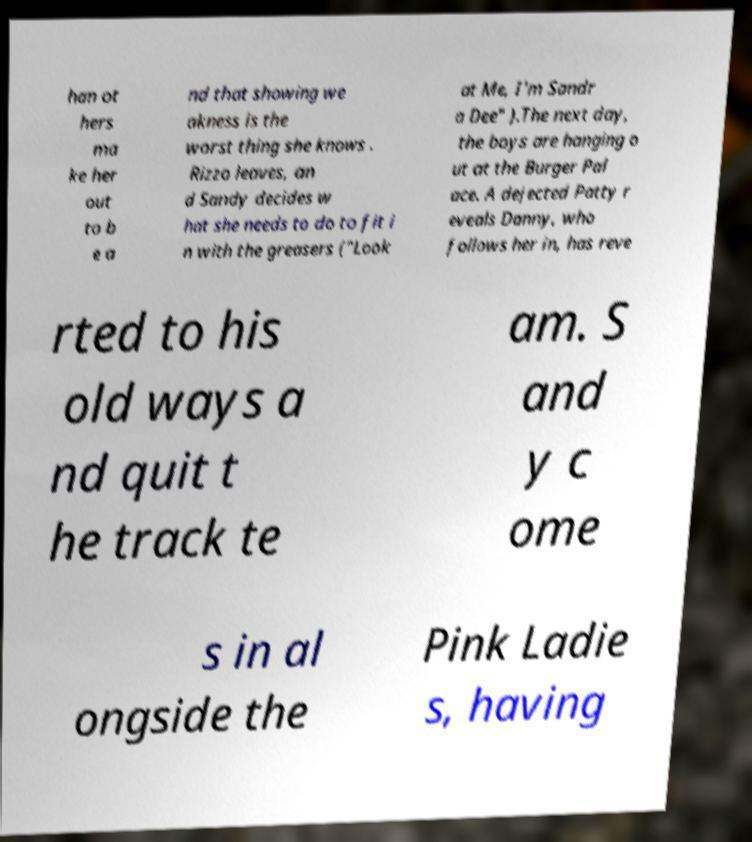I need the written content from this picture converted into text. Can you do that? han ot hers ma ke her out to b e a nd that showing we akness is the worst thing she knows . Rizzo leaves, an d Sandy decides w hat she needs to do to fit i n with the greasers ("Look at Me, I'm Sandr a Dee" ).The next day, the boys are hanging o ut at the Burger Pal ace. A dejected Patty r eveals Danny, who follows her in, has reve rted to his old ways a nd quit t he track te am. S and y c ome s in al ongside the Pink Ladie s, having 